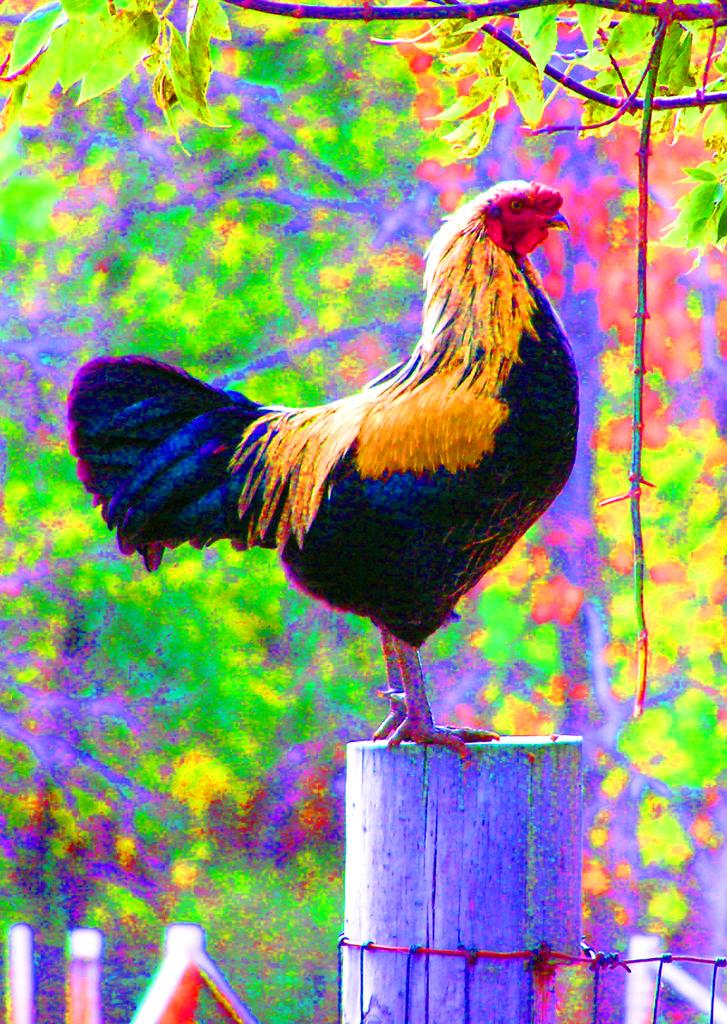What animal is present in the image? There is a cock in the image. What is the cock standing on? The cock is standing on a wooden pole. What is near the wooden pole? The wooden pole is near a fencing. What can be seen in the background of the image? There are trees in the background of the image. What type of crime is being committed in the image? There is no crime being committed in the image; it features a cock standing on a wooden pole near a fencing. Can you see a band playing in the image? There is no band present in the image. 